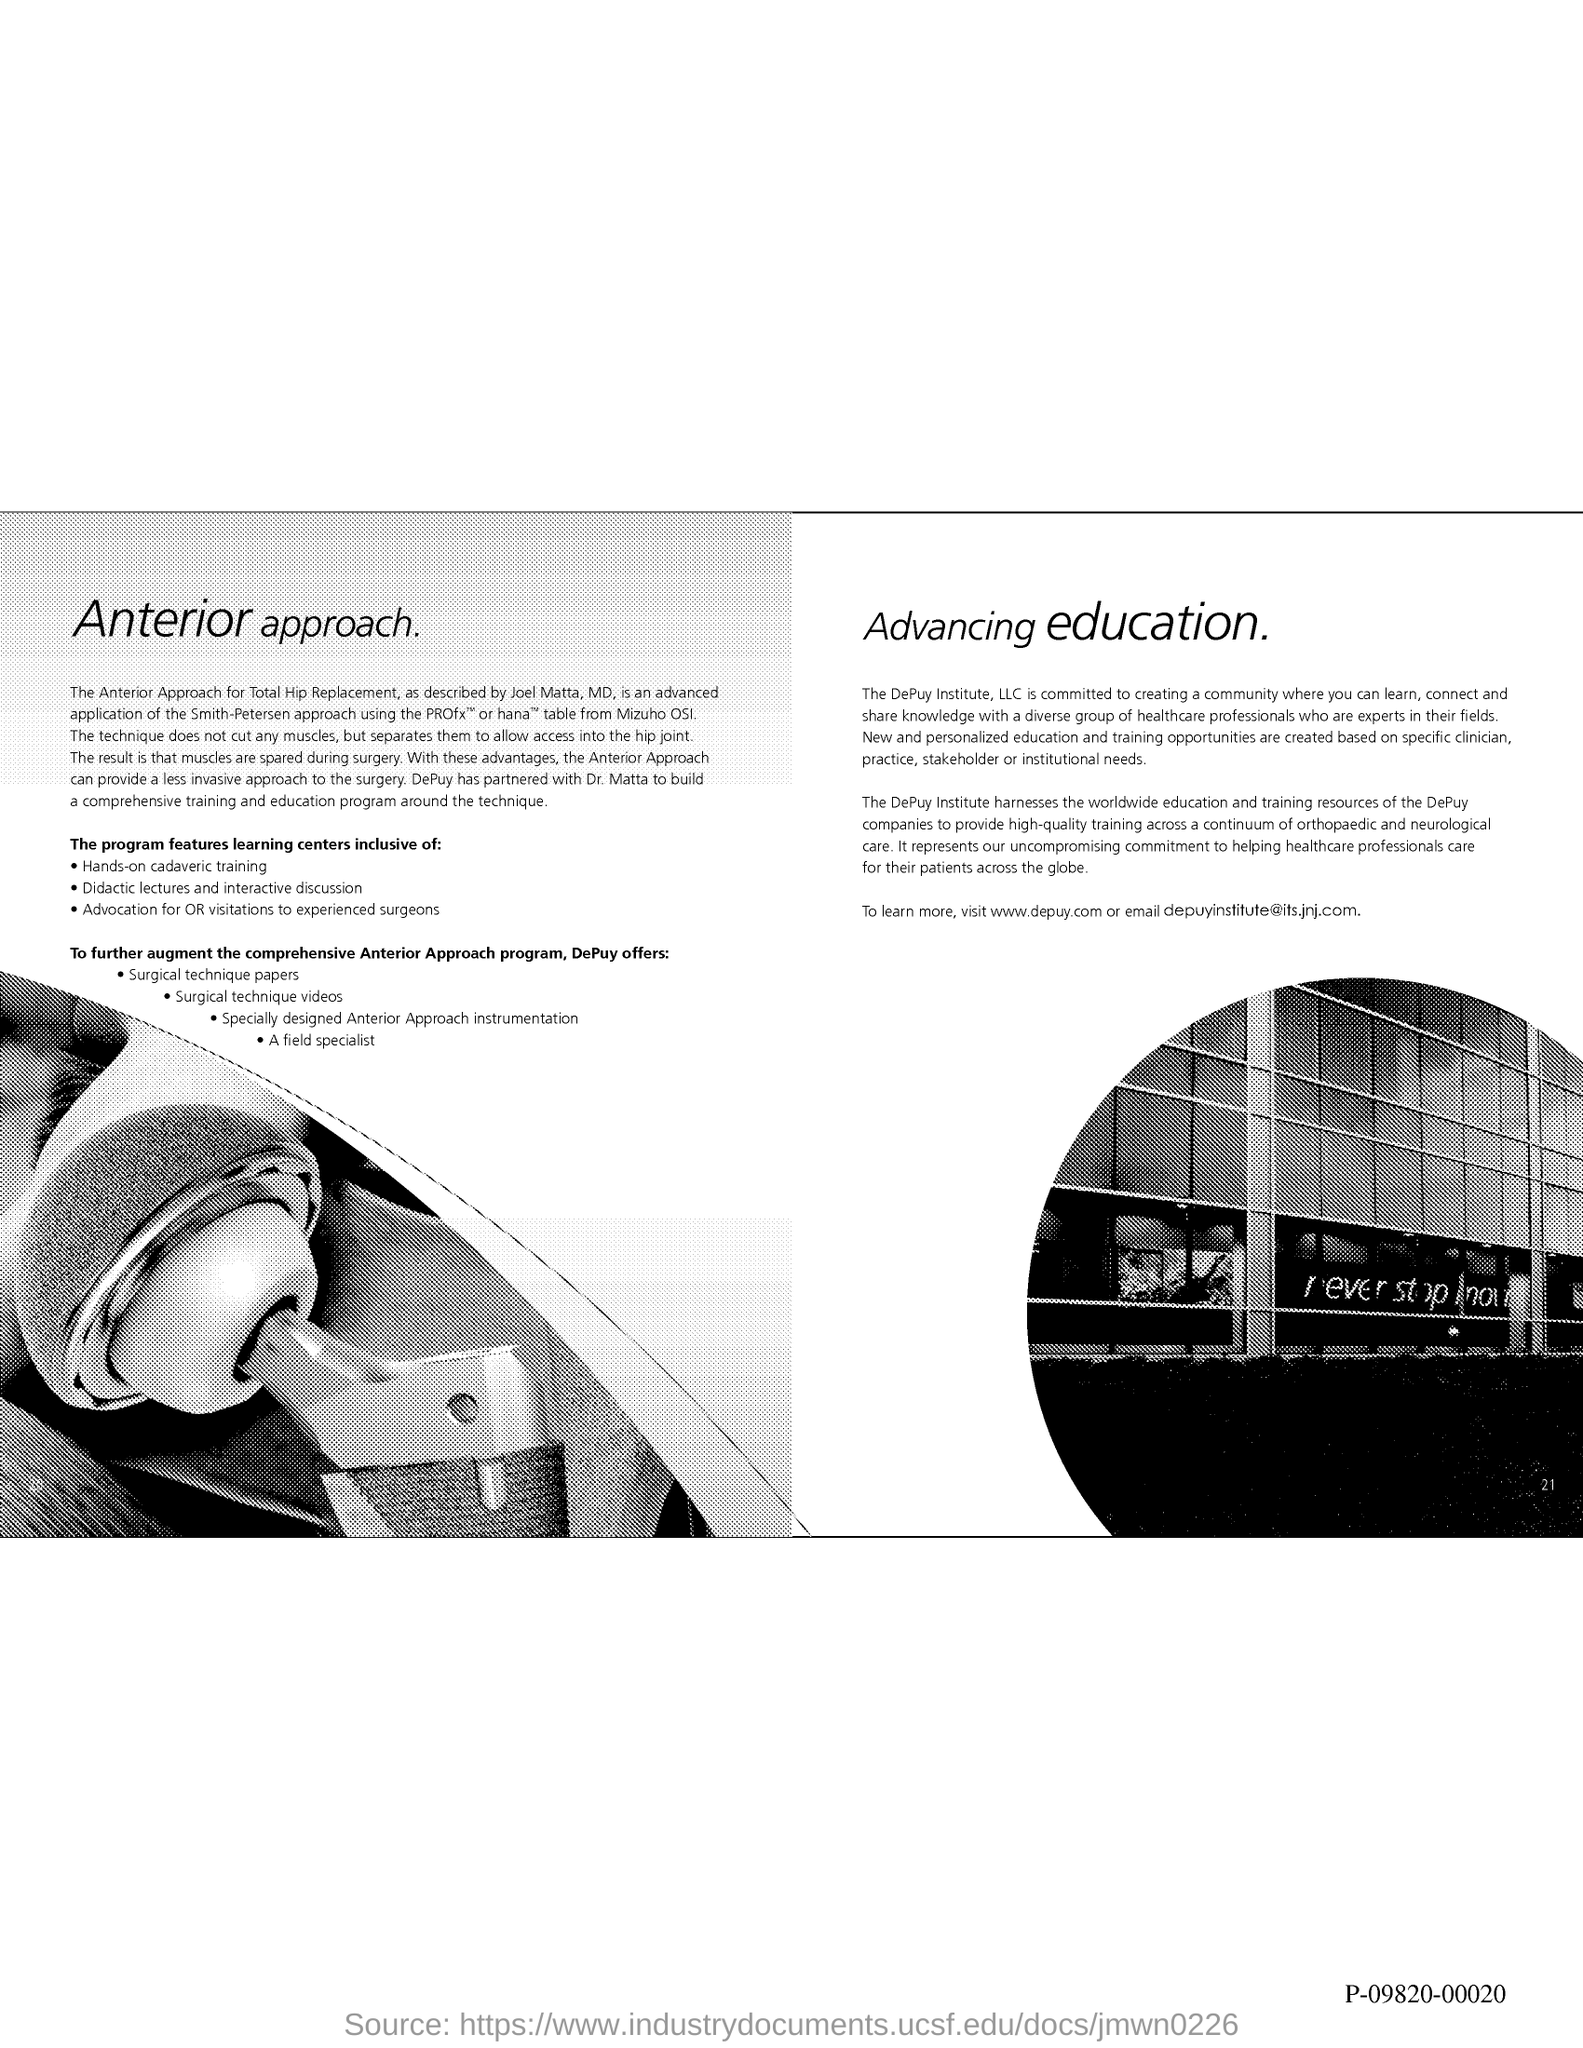Which website to visit to learn more?
Ensure brevity in your answer.  Www.depuy.com. What is the email?
Ensure brevity in your answer.  Depuyinstitute@its.jnj.com. 